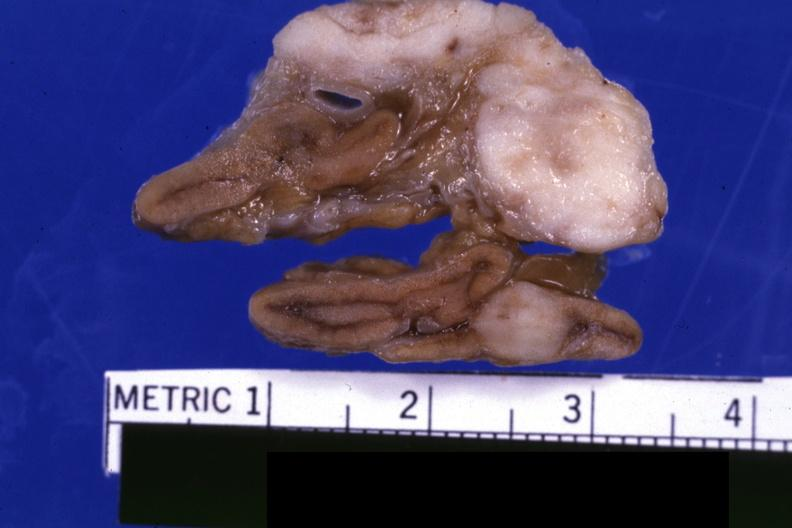what does this image show?
Answer the question using a single word or phrase. Fixed tissue close-up view shows tumor very well lung adenocarcinoma 